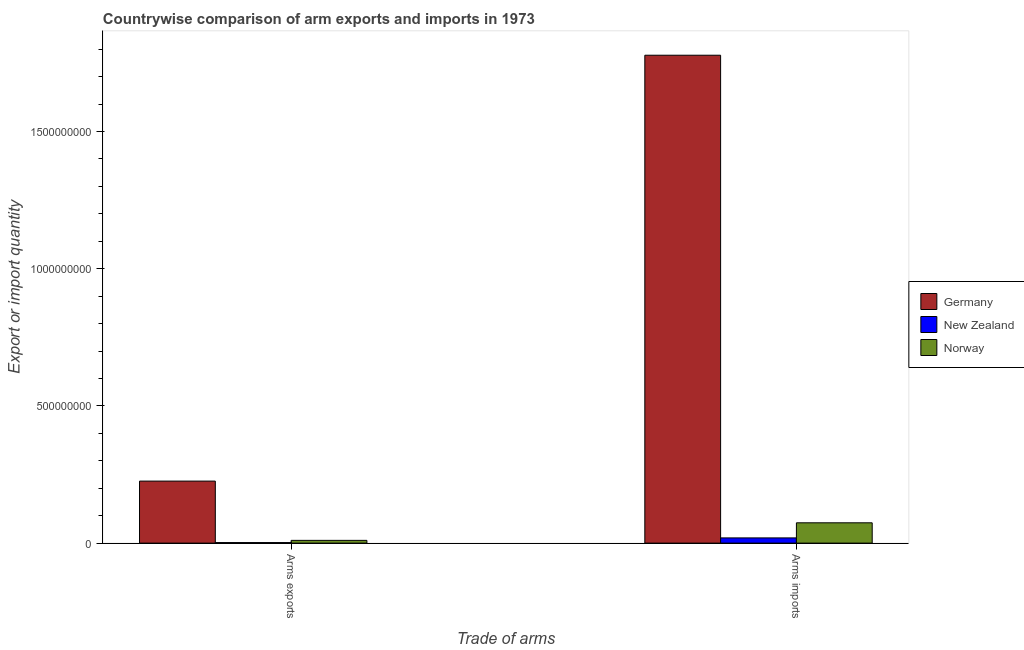Are the number of bars per tick equal to the number of legend labels?
Offer a very short reply. Yes. Are the number of bars on each tick of the X-axis equal?
Give a very brief answer. Yes. How many bars are there on the 2nd tick from the right?
Provide a succinct answer. 3. What is the label of the 2nd group of bars from the left?
Make the answer very short. Arms imports. What is the arms exports in Germany?
Give a very brief answer. 2.26e+08. Across all countries, what is the maximum arms exports?
Keep it short and to the point. 2.26e+08. Across all countries, what is the minimum arms exports?
Your answer should be compact. 2.00e+06. In which country was the arms exports maximum?
Your response must be concise. Germany. In which country was the arms exports minimum?
Your answer should be very brief. New Zealand. What is the total arms exports in the graph?
Provide a short and direct response. 2.38e+08. What is the difference between the arms exports in Norway and that in Germany?
Make the answer very short. -2.16e+08. What is the difference between the arms imports in Norway and the arms exports in New Zealand?
Your response must be concise. 7.20e+07. What is the average arms imports per country?
Give a very brief answer. 6.24e+08. What is the difference between the arms imports and arms exports in New Zealand?
Keep it short and to the point. 1.70e+07. In how many countries, is the arms imports greater than 100000000 ?
Provide a succinct answer. 1. What is the ratio of the arms exports in New Zealand to that in Germany?
Provide a short and direct response. 0.01. Is the arms imports in Germany less than that in New Zealand?
Make the answer very short. No. What is the difference between two consecutive major ticks on the Y-axis?
Give a very brief answer. 5.00e+08. Are the values on the major ticks of Y-axis written in scientific E-notation?
Offer a very short reply. No. Does the graph contain any zero values?
Keep it short and to the point. No. Does the graph contain grids?
Your answer should be very brief. No. How many legend labels are there?
Offer a very short reply. 3. How are the legend labels stacked?
Your answer should be compact. Vertical. What is the title of the graph?
Offer a terse response. Countrywise comparison of arm exports and imports in 1973. What is the label or title of the X-axis?
Provide a short and direct response. Trade of arms. What is the label or title of the Y-axis?
Provide a short and direct response. Export or import quantity. What is the Export or import quantity of Germany in Arms exports?
Offer a terse response. 2.26e+08. What is the Export or import quantity of New Zealand in Arms exports?
Make the answer very short. 2.00e+06. What is the Export or import quantity of Norway in Arms exports?
Provide a short and direct response. 1.00e+07. What is the Export or import quantity of Germany in Arms imports?
Your answer should be compact. 1.78e+09. What is the Export or import quantity of New Zealand in Arms imports?
Your response must be concise. 1.90e+07. What is the Export or import quantity of Norway in Arms imports?
Offer a very short reply. 7.40e+07. Across all Trade of arms, what is the maximum Export or import quantity in Germany?
Provide a short and direct response. 1.78e+09. Across all Trade of arms, what is the maximum Export or import quantity in New Zealand?
Give a very brief answer. 1.90e+07. Across all Trade of arms, what is the maximum Export or import quantity in Norway?
Provide a short and direct response. 7.40e+07. Across all Trade of arms, what is the minimum Export or import quantity of Germany?
Your answer should be compact. 2.26e+08. Across all Trade of arms, what is the minimum Export or import quantity in Norway?
Ensure brevity in your answer.  1.00e+07. What is the total Export or import quantity of Germany in the graph?
Your answer should be very brief. 2.00e+09. What is the total Export or import quantity of New Zealand in the graph?
Your answer should be compact. 2.10e+07. What is the total Export or import quantity in Norway in the graph?
Your answer should be compact. 8.40e+07. What is the difference between the Export or import quantity in Germany in Arms exports and that in Arms imports?
Offer a very short reply. -1.55e+09. What is the difference between the Export or import quantity in New Zealand in Arms exports and that in Arms imports?
Ensure brevity in your answer.  -1.70e+07. What is the difference between the Export or import quantity of Norway in Arms exports and that in Arms imports?
Provide a short and direct response. -6.40e+07. What is the difference between the Export or import quantity in Germany in Arms exports and the Export or import quantity in New Zealand in Arms imports?
Offer a very short reply. 2.07e+08. What is the difference between the Export or import quantity in Germany in Arms exports and the Export or import quantity in Norway in Arms imports?
Keep it short and to the point. 1.52e+08. What is the difference between the Export or import quantity in New Zealand in Arms exports and the Export or import quantity in Norway in Arms imports?
Offer a very short reply. -7.20e+07. What is the average Export or import quantity of Germany per Trade of arms?
Provide a succinct answer. 1.00e+09. What is the average Export or import quantity of New Zealand per Trade of arms?
Your response must be concise. 1.05e+07. What is the average Export or import quantity of Norway per Trade of arms?
Offer a terse response. 4.20e+07. What is the difference between the Export or import quantity in Germany and Export or import quantity in New Zealand in Arms exports?
Offer a very short reply. 2.24e+08. What is the difference between the Export or import quantity in Germany and Export or import quantity in Norway in Arms exports?
Your answer should be very brief. 2.16e+08. What is the difference between the Export or import quantity of New Zealand and Export or import quantity of Norway in Arms exports?
Make the answer very short. -8.00e+06. What is the difference between the Export or import quantity in Germany and Export or import quantity in New Zealand in Arms imports?
Offer a terse response. 1.76e+09. What is the difference between the Export or import quantity in Germany and Export or import quantity in Norway in Arms imports?
Provide a short and direct response. 1.70e+09. What is the difference between the Export or import quantity in New Zealand and Export or import quantity in Norway in Arms imports?
Offer a very short reply. -5.50e+07. What is the ratio of the Export or import quantity in Germany in Arms exports to that in Arms imports?
Your answer should be compact. 0.13. What is the ratio of the Export or import quantity in New Zealand in Arms exports to that in Arms imports?
Your response must be concise. 0.11. What is the ratio of the Export or import quantity in Norway in Arms exports to that in Arms imports?
Your answer should be compact. 0.14. What is the difference between the highest and the second highest Export or import quantity of Germany?
Your response must be concise. 1.55e+09. What is the difference between the highest and the second highest Export or import quantity in New Zealand?
Your answer should be very brief. 1.70e+07. What is the difference between the highest and the second highest Export or import quantity of Norway?
Give a very brief answer. 6.40e+07. What is the difference between the highest and the lowest Export or import quantity in Germany?
Give a very brief answer. 1.55e+09. What is the difference between the highest and the lowest Export or import quantity in New Zealand?
Your response must be concise. 1.70e+07. What is the difference between the highest and the lowest Export or import quantity in Norway?
Give a very brief answer. 6.40e+07. 